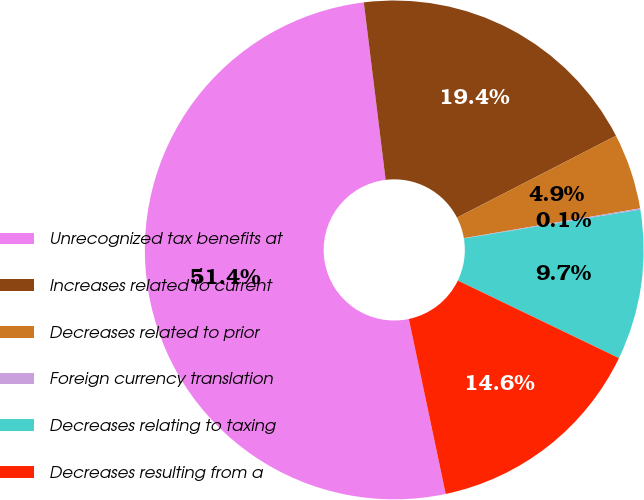Convert chart to OTSL. <chart><loc_0><loc_0><loc_500><loc_500><pie_chart><fcel>Unrecognized tax benefits at<fcel>Increases related to current<fcel>Decreases related to prior<fcel>Foreign currency translation<fcel>Decreases relating to taxing<fcel>Decreases resulting from a<nl><fcel>51.36%<fcel>19.38%<fcel>4.9%<fcel>0.08%<fcel>9.73%<fcel>14.55%<nl></chart> 